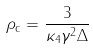<formula> <loc_0><loc_0><loc_500><loc_500>\rho _ { \text {c} } = \frac { 3 } { \kappa _ { 4 } \gamma ^ { 2 } \Delta }</formula> 